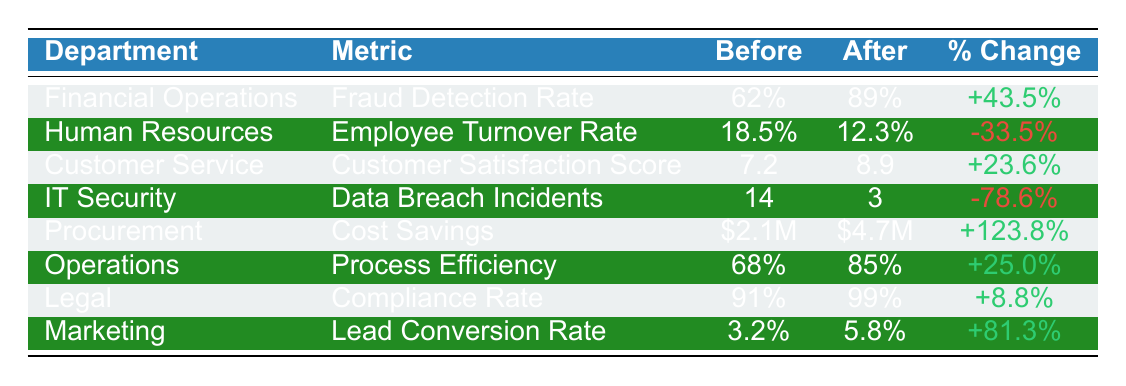What was the Fraud Detection Rate after implementation? According to the table, the Fraud Detection Rate for the Financial Operations department after implementation was 89%.
Answer: 89% Which department had the highest percentage change in cost savings? The Procurement department had a percentage change of +123.8%, which is the highest among all departments in the table.
Answer: Procurement What is the percentage change in the Employee Turnover Rate? The Employee Turnover Rate decreased from 18.5% to 12.3%, resulting in a percentage change of -33.5%.
Answer: -33.5% Which metric improved the least after implementation, and what was the percentage change? The Compliance Rate in the Legal department improved the least, with a percentage change of +8.8%.
Answer: +8.8% Is there a department that showed an increase in its metric value after implementation? Yes, several departments showed an increase; for example, Financial Operations increased its Fraud Detection Rate from 62% to 89%.
Answer: Yes What is the average percentage change across all departments? To find the average percentage change, we can sum the individual percentage changes: 43.5 + (-33.5) + 23.6 + (-78.6) + 123.8 + 25.0 + 8.8 + 81.3 = 170.2, then divide by 8. The average is 170.2 / 8 = 21.275%.
Answer: 21.275% How many departments had a decrease in their respective metrics? Two departments showed a decrease: Human Resources (Employee Turnover Rate) and IT Security (Data Breach Incidents).
Answer: 2 Which department improved their customer satisfaction score the most? The Customer Service department improved its satisfaction score from 7.2 to 8.9, resulting in an increase of +23.6%.
Answer: Customer Service If we compare the Fraud Detection Rate and the Data Breach Incidents, which department had a better performance after implementation? The Financial Operations department had a Fraud Detection Rate of 89%, while the IT Security department had only 3 Data Breach Incidents, indicating a better performance in terms of fraud detection.
Answer: Financial Operations Was there any department that achieved a metric score of 99% after implementation? Yes, the Legal department achieved a Compliance Rate of 99% after implementation.
Answer: Yes Did any department experience both high improvement in scores and high percentage change? Yes, the Procurement department saw a high improvement in Cost Savings with a percentage change of +123.8%, indicating significant effectiveness post-implementation.
Answer: Yes 